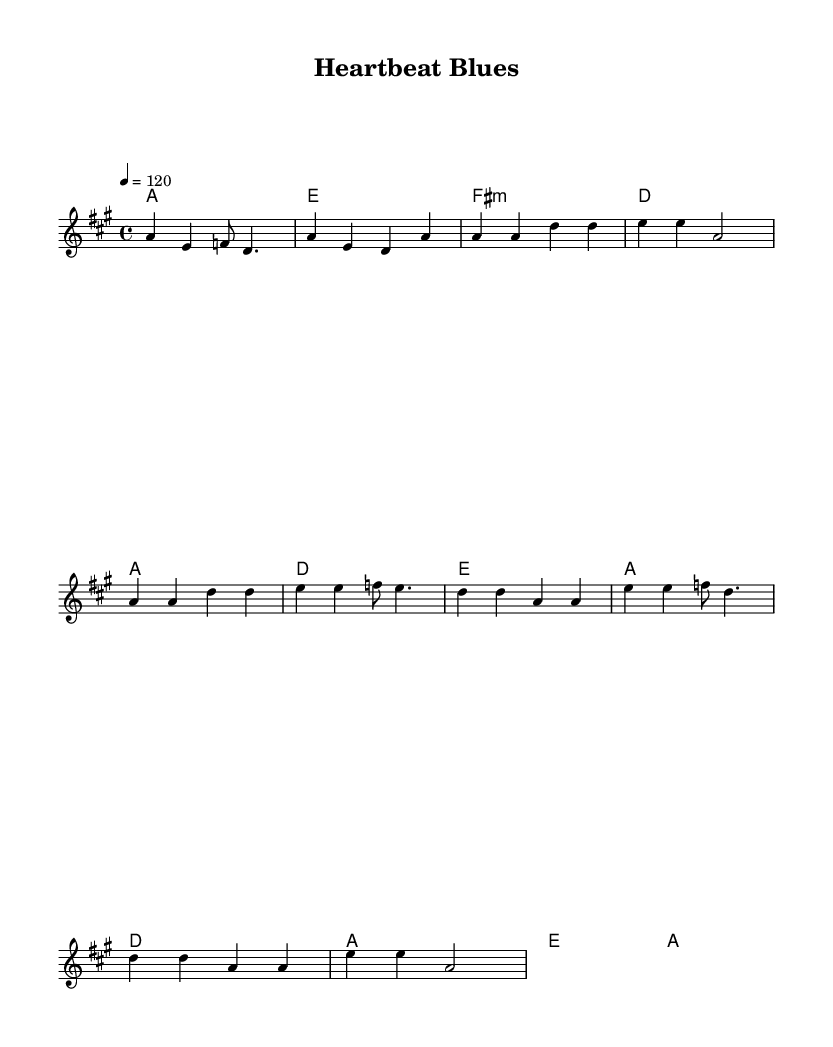What is the key signature of this music? The key signature is A major, which contains three sharps (F#, C#, and G#). This is indicated at the beginning of the sheet music.
Answer: A major What is the time signature of this music? The time signature is 4/4, meaning there are four beats per measure. This is visible right after the clef and key signature at the start of the sheet music.
Answer: 4/4 What is the tempo marking of this piece? The tempo marking is 120, indicating the piece should be played at 120 beats per minute. It is written as "4 = 120" in the tempo section of the score.
Answer: 120 How many measures are in the melody section? The melody section has 12 measures. By counting each measure separated by bar lines, you can verify the total number present.
Answer: 12 What type of harmony is used in the chorus? The chorus contains major harmonies, as evidenced by the chords outlined, specifically A major and D major. The chord symbols above the staff show this.
Answer: Major What is the rhythm pattern primarily used in the verse? The rhythm pattern in the verse primarily uses quarter notes and dotted notes, as indicated by the note values written in the melody line.
Answer: Quarter notes and dotted notes What genre does this song belong to? This song belongs to the blues-rock genre, characterized by its upbeat rhythm and catchy pop hooks, which is evident from the style and tempo indicated as well as the overall structure.
Answer: Blues-rock 